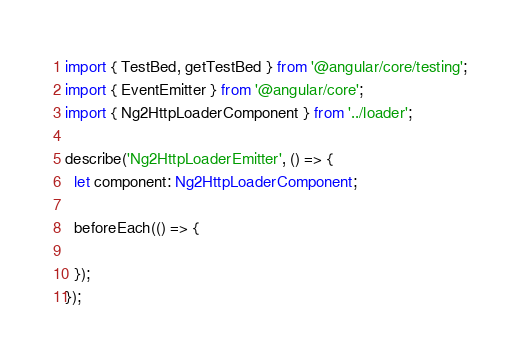<code> <loc_0><loc_0><loc_500><loc_500><_TypeScript_>import { TestBed, getTestBed } from '@angular/core/testing';
import { EventEmitter } from '@angular/core';
import { Ng2HttpLoaderComponent } from '../loader';

describe('Ng2HttpLoaderEmitter', () => {
  let component: Ng2HttpLoaderComponent;

  beforeEach(() => {
    
  });
});</code> 